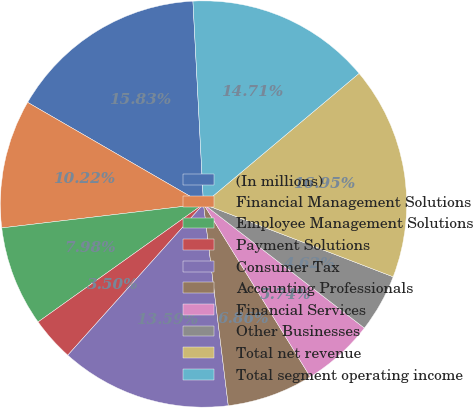Convert chart. <chart><loc_0><loc_0><loc_500><loc_500><pie_chart><fcel>(In millions)<fcel>Financial Management Solutions<fcel>Employee Management Solutions<fcel>Payment Solutions<fcel>Consumer Tax<fcel>Accounting Professionals<fcel>Financial Services<fcel>Other Businesses<fcel>Total net revenue<fcel>Total segment operating income<nl><fcel>15.83%<fcel>10.22%<fcel>7.98%<fcel>3.5%<fcel>13.59%<fcel>6.86%<fcel>5.74%<fcel>4.62%<fcel>16.95%<fcel>14.71%<nl></chart> 